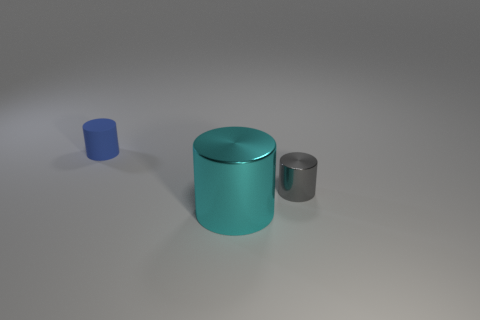Are there more tiny purple shiny blocks than large cyan metal cylinders?
Provide a short and direct response. No. The cyan thing has what size?
Give a very brief answer. Large. What number of other things are there of the same color as the big metallic object?
Offer a terse response. 0. Is the tiny thing to the left of the large cyan metal object made of the same material as the cyan thing?
Give a very brief answer. No. Is the number of small gray cylinders in front of the tiny rubber object less than the number of metal things that are in front of the tiny gray metallic object?
Ensure brevity in your answer.  No. How many other objects are there of the same material as the tiny gray cylinder?
Provide a succinct answer. 1. There is another cylinder that is the same size as the blue rubber cylinder; what material is it?
Make the answer very short. Metal. Is the number of blue matte cylinders on the right side of the tiny blue rubber object less than the number of cyan metallic things?
Provide a succinct answer. Yes. What is the shape of the metal thing that is in front of the tiny shiny cylinder that is right of the metal cylinder that is to the left of the gray shiny thing?
Ensure brevity in your answer.  Cylinder. How big is the object behind the gray cylinder?
Make the answer very short. Small. 